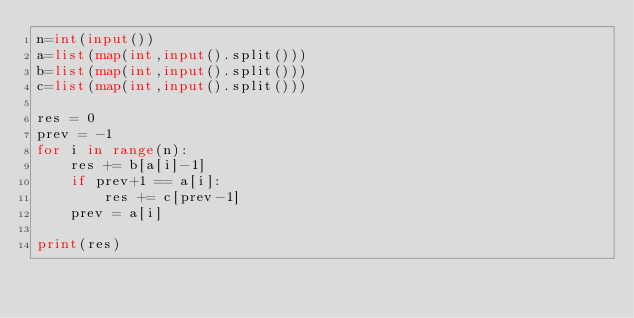Convert code to text. <code><loc_0><loc_0><loc_500><loc_500><_Python_>n=int(input())
a=list(map(int,input().split()))
b=list(map(int,input().split()))
c=list(map(int,input().split()))

res = 0
prev = -1
for i in range(n):
    res += b[a[i]-1]
    if prev+1 == a[i]:
        res += c[prev-1]
    prev = a[i]

print(res)
</code> 